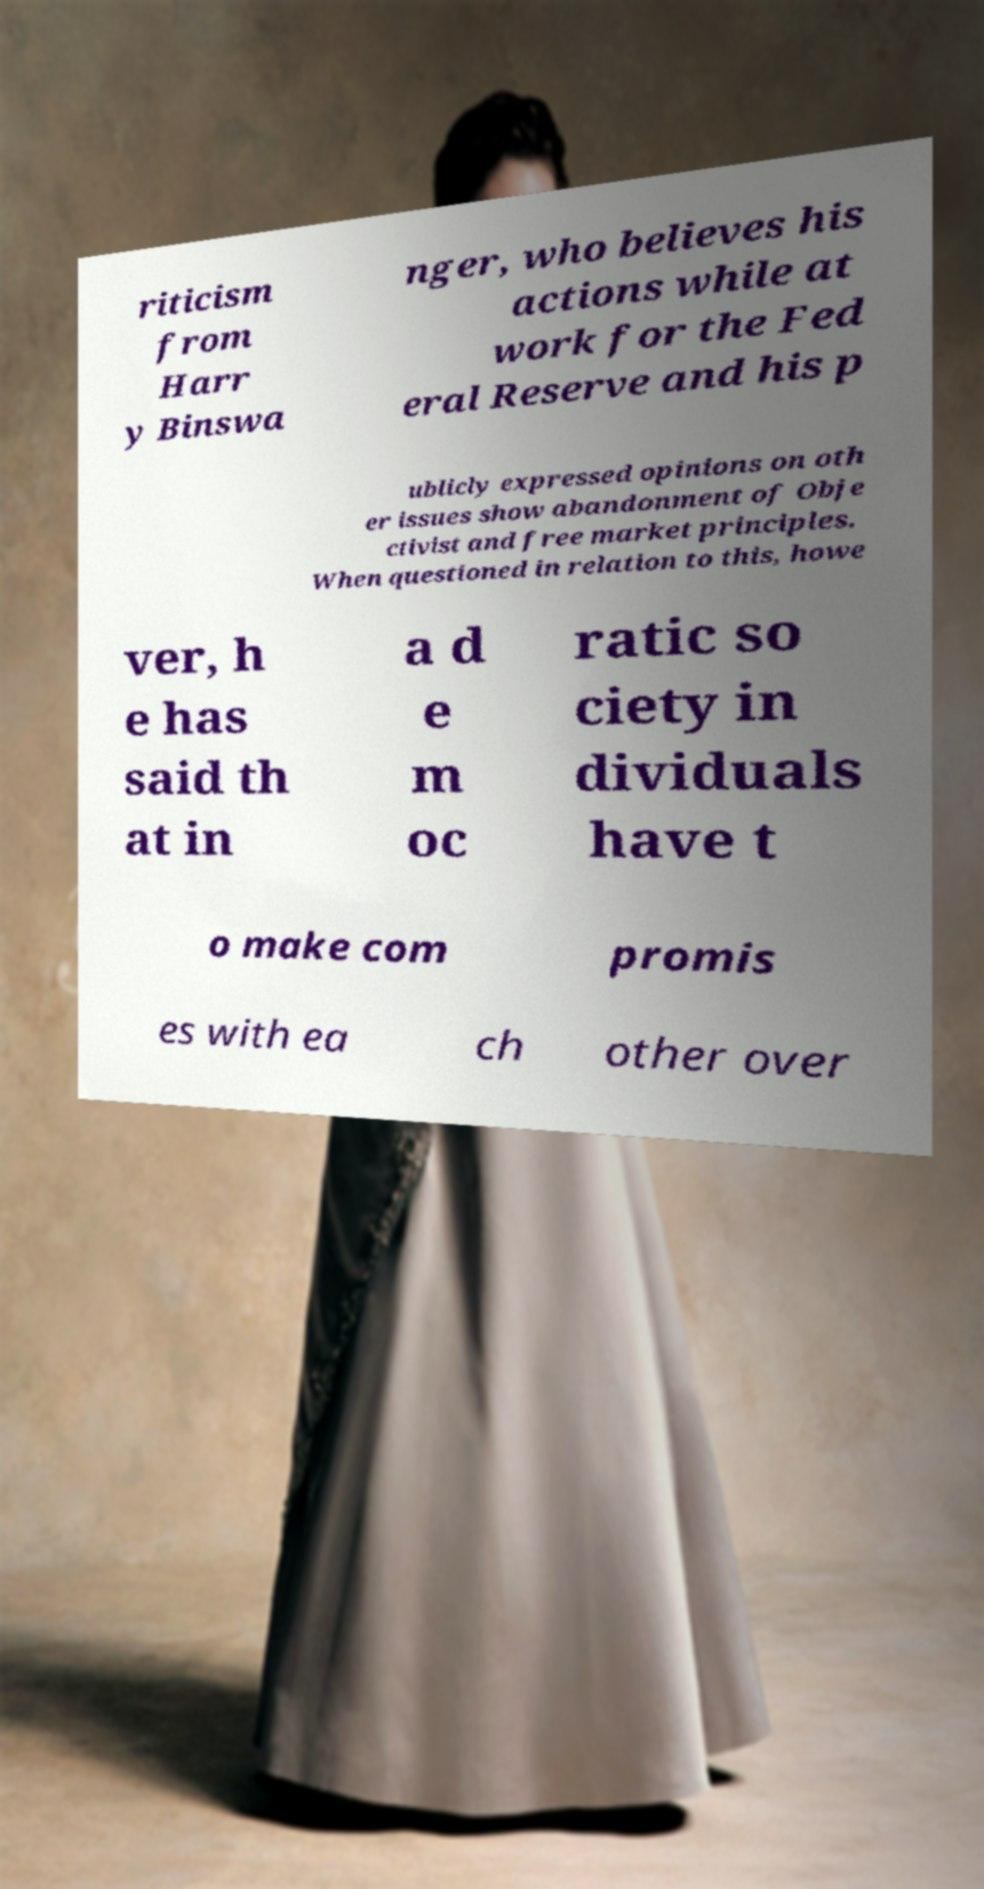Could you extract and type out the text from this image? riticism from Harr y Binswa nger, who believes his actions while at work for the Fed eral Reserve and his p ublicly expressed opinions on oth er issues show abandonment of Obje ctivist and free market principles. When questioned in relation to this, howe ver, h e has said th at in a d e m oc ratic so ciety in dividuals have t o make com promis es with ea ch other over 